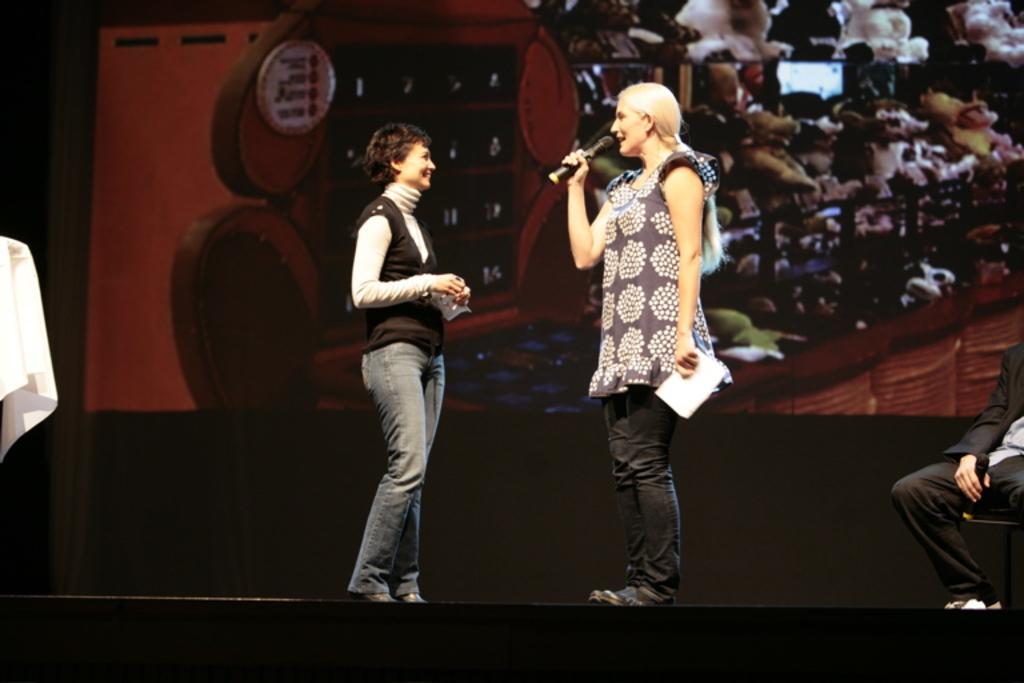How would you summarize this image in a sentence or two? There are two women standing. This woman is holding a mike and a paper in her hands. I can see a person holding a mike and sitting on the chair. This looks like a banner. 